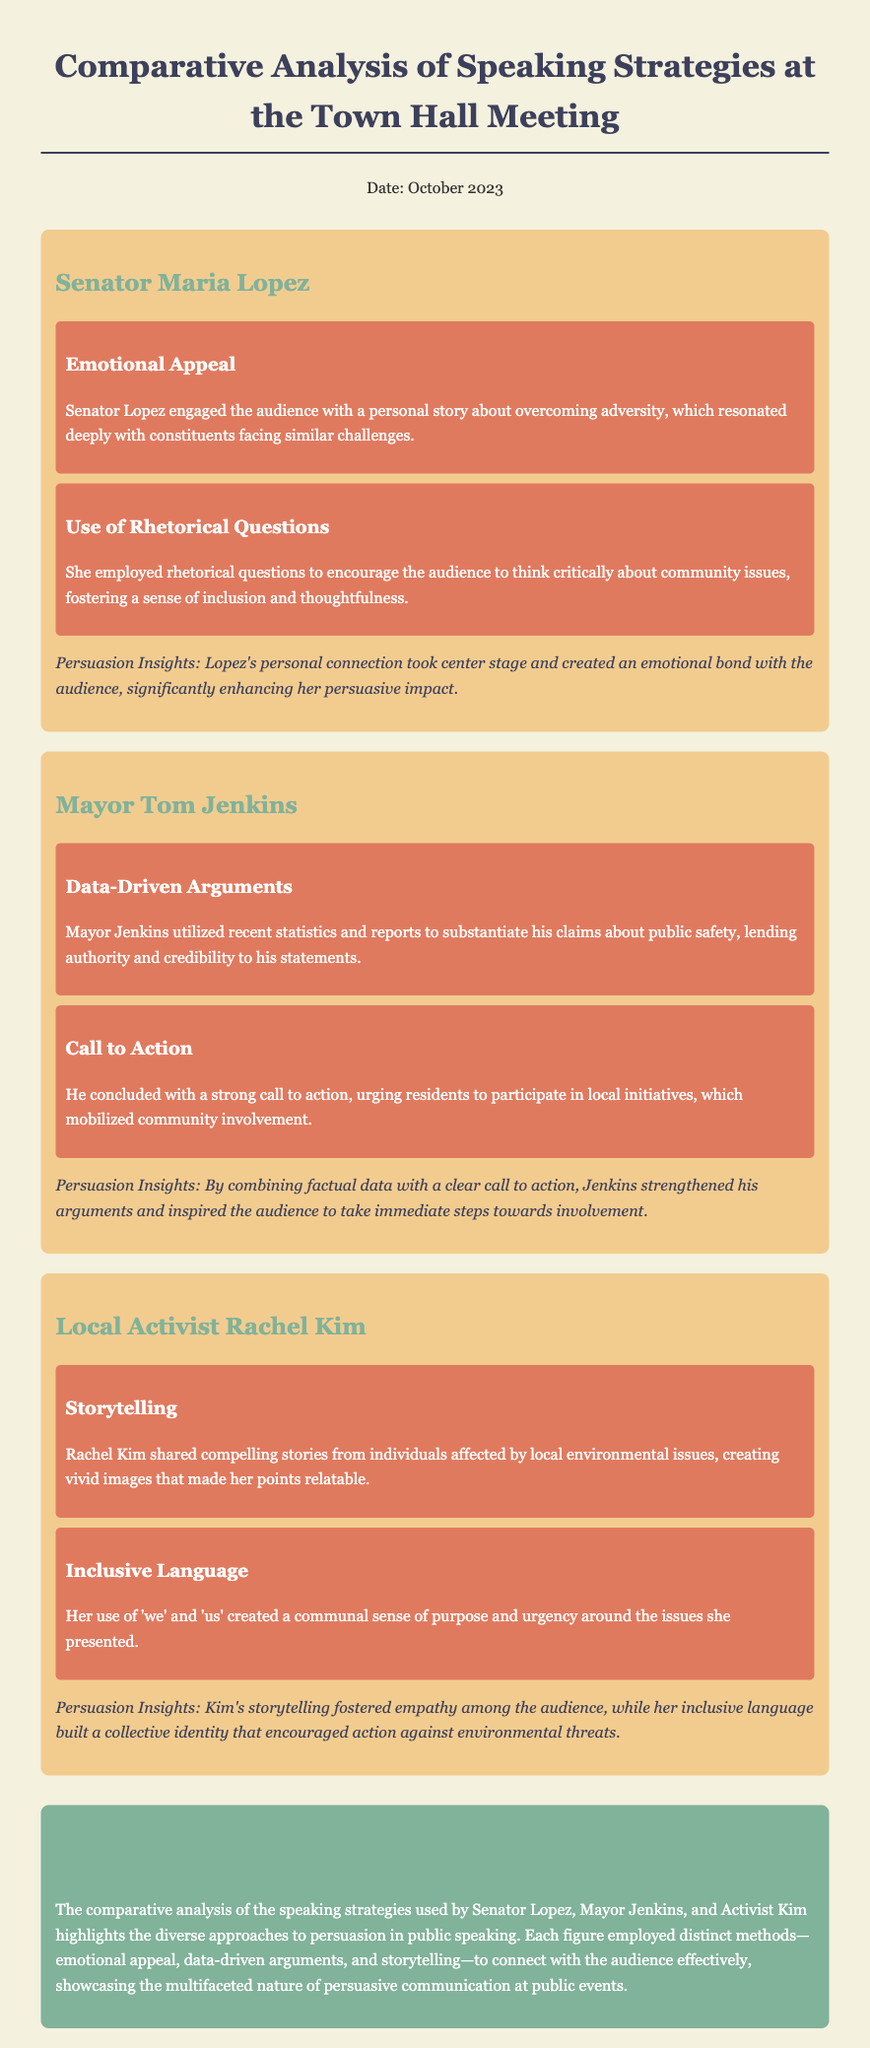What speaking strategy did Senator Lopez use to connect with the audience? Senator Lopez engaged the audience with a personal story about overcoming adversity, which resonated deeply with constituents facing similar challenges.
Answer: Emotional Appeal What data strategy did Mayor Jenkins use in his speech? Mayor Jenkins utilized recent statistics and reports to substantiate his claims about public safety, lending authority and credibility to his statements.
Answer: Data-Driven Arguments What is one persuasive insight from Rachel Kim's speech? Kim's storytelling fostered empathy among the audience, while her inclusive language built a collective identity that encouraged action against environmental threats.
Answer: Empathy What did Mayor Jenkins conclude his speech with? He concluded with a strong call to action, urging residents to participate in local initiatives, which mobilized community involvement.
Answer: Call to Action Which speaker used inclusive language in their speech? Rachel Kim used 'we' and 'us' creating a communal sense of purpose and urgency around the issues she presented.
Answer: Rachel Kim How many strategies did Senator Lopez use in her speech? Senator Lopez employed multiple strategies, which are Emotional Appeal and Use of Rhetorical Questions, making a total of two strategies.
Answer: Two What date was the town hall meeting memo dated? The date of the town hall meeting memo was mentioned explicitly in the document.
Answer: October 2023 What approach did all three speakers take in their speaking strategies? Each figure employed distinct methods—emotional appeal, data-driven arguments, and storytelling—to connect with the audience effectively.
Answer: Distinct methods 